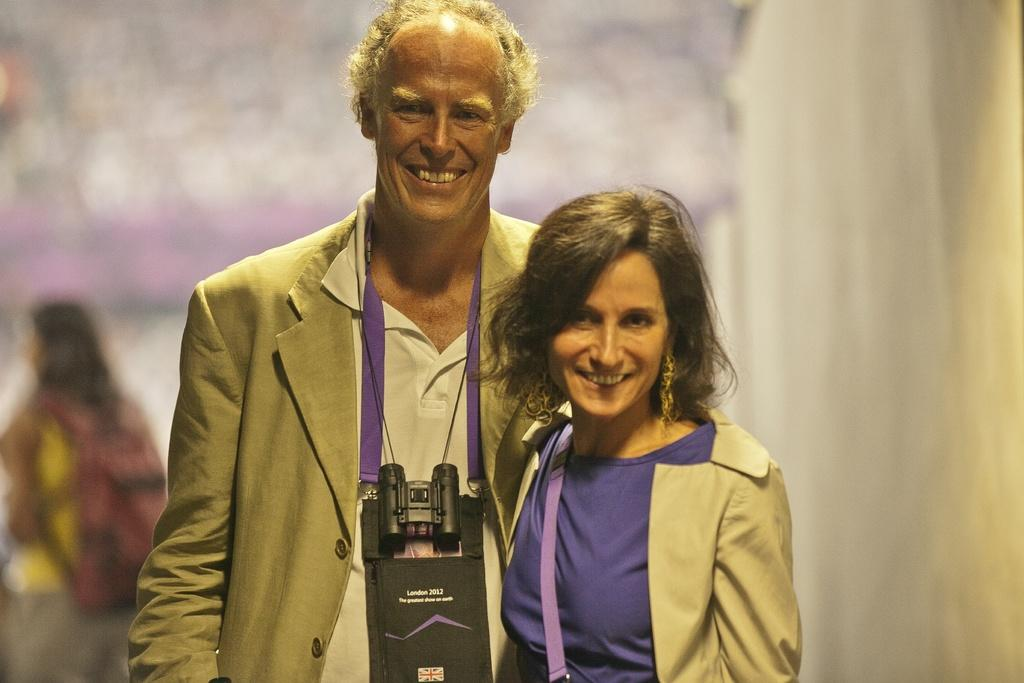How many people are in the image? There are three people in the image. What are the people in the middle of the image doing? The two persons in the middle of the image are standing and smiling. Can you describe the person behind them? There is a person standing behind the two people in the middle of the image. What can be observed about the background of the image? The background of the image is blurred. How many dogs are visible in the image? There are no dogs present in the image. What type of shoes are the people wearing in the image? The provided facts do not mention any shoes worn by the people in the image. 